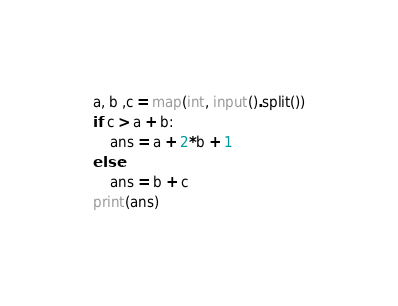Convert code to text. <code><loc_0><loc_0><loc_500><loc_500><_Python_>a, b ,c = map(int, input().split())
if c > a + b:
    ans = a + 2*b + 1
else:
    ans = b + c
print(ans)
</code> 